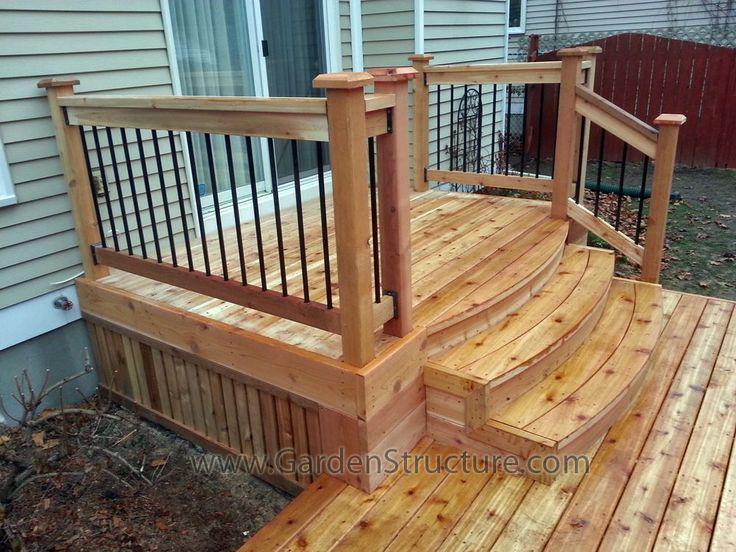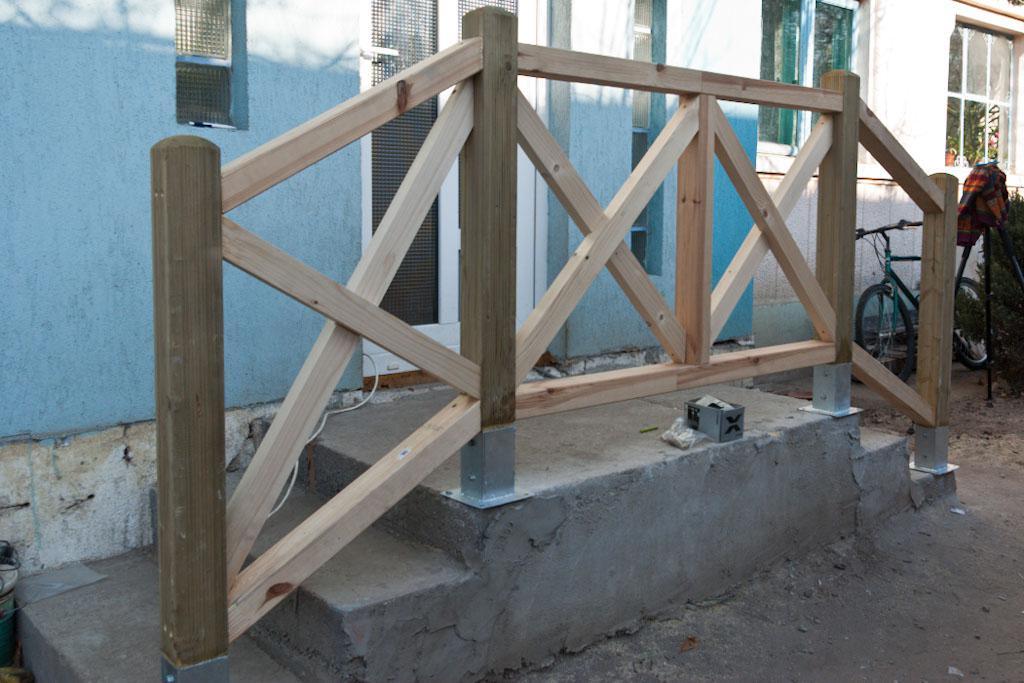The first image is the image on the left, the second image is the image on the right. Considering the images on both sides, is "The left image contains one human doing carpentry." valid? Answer yes or no. No. The first image is the image on the left, the second image is the image on the right. Given the left and right images, does the statement "In one image, a wooden deck with ballustrade and set of stairs is outside the double doors of a house." hold true? Answer yes or no. Yes. 